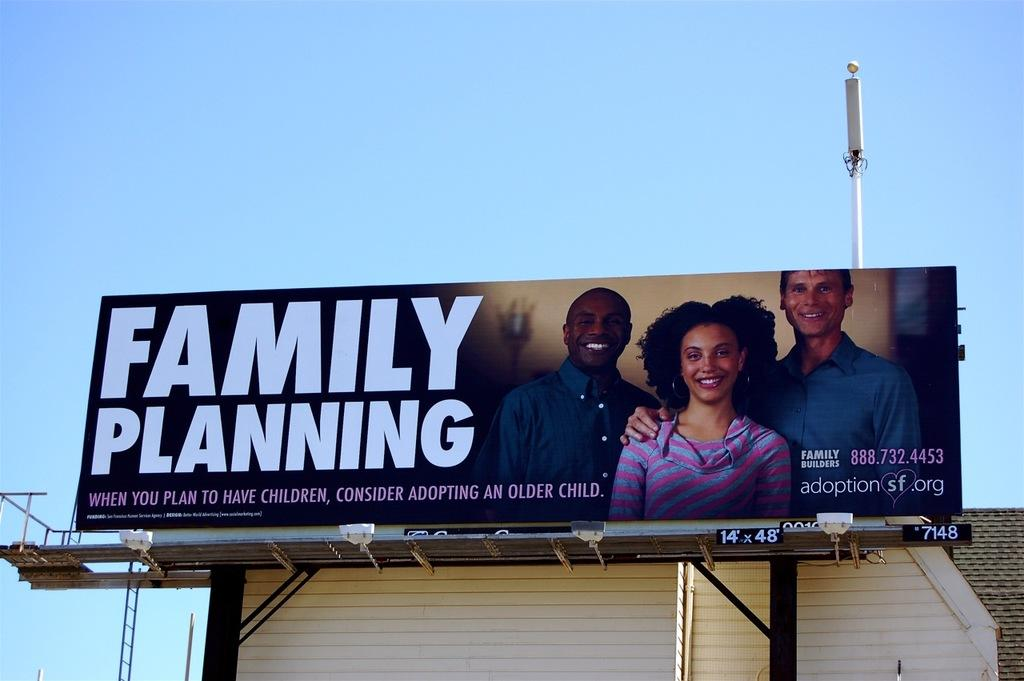Provide a one-sentence caption for the provided image. Billboard outdoors that says "Family Planning" on it. 